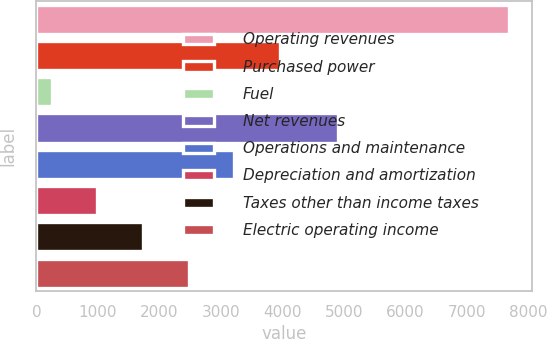<chart> <loc_0><loc_0><loc_500><loc_500><bar_chart><fcel>Operating revenues<fcel>Purchased power<fcel>Fuel<fcel>Net revenues<fcel>Operations and maintenance<fcel>Depreciation and amortization<fcel>Taxes other than income taxes<fcel>Electric operating income<nl><fcel>7674<fcel>3960.5<fcel>247<fcel>4898<fcel>3217.8<fcel>989.7<fcel>1732.4<fcel>2475.1<nl></chart> 